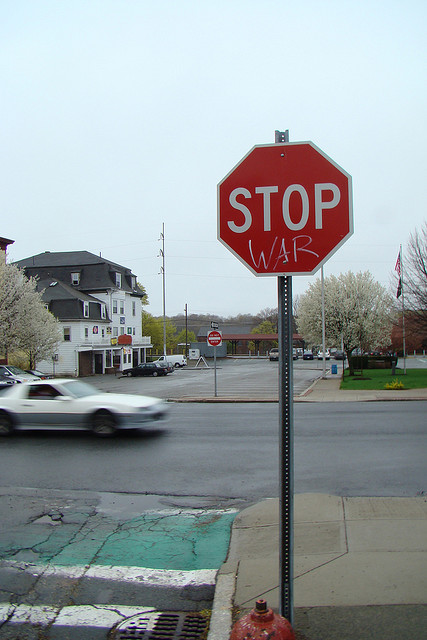How might this image reflect historical or current events? This image may be reflective of a period of conflict or war, either historically or contemporaneously. It might be a response to a specific war or general opposition to militarism. The message 'STOP WAR' signifies a desire for peace and could reflect nationwide or global protests, calls for disarmament, or peace negotiations relevant to the time it was created. 